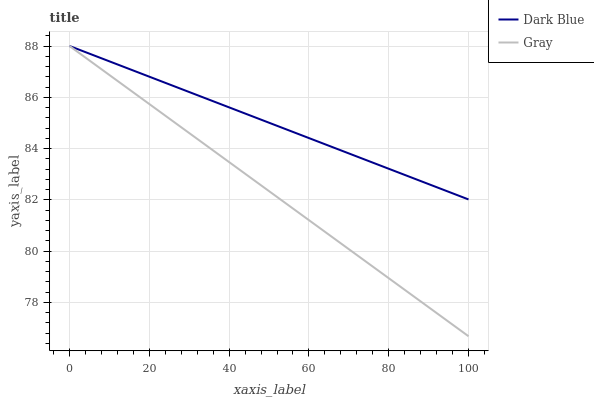Does Gray have the minimum area under the curve?
Answer yes or no. Yes. Does Dark Blue have the maximum area under the curve?
Answer yes or no. Yes. Does Gray have the maximum area under the curve?
Answer yes or no. No. Is Gray the smoothest?
Answer yes or no. Yes. Is Dark Blue the roughest?
Answer yes or no. Yes. Is Gray the roughest?
Answer yes or no. No. Does Gray have the lowest value?
Answer yes or no. Yes. Does Gray have the highest value?
Answer yes or no. Yes. Does Dark Blue intersect Gray?
Answer yes or no. Yes. Is Dark Blue less than Gray?
Answer yes or no. No. Is Dark Blue greater than Gray?
Answer yes or no. No. 